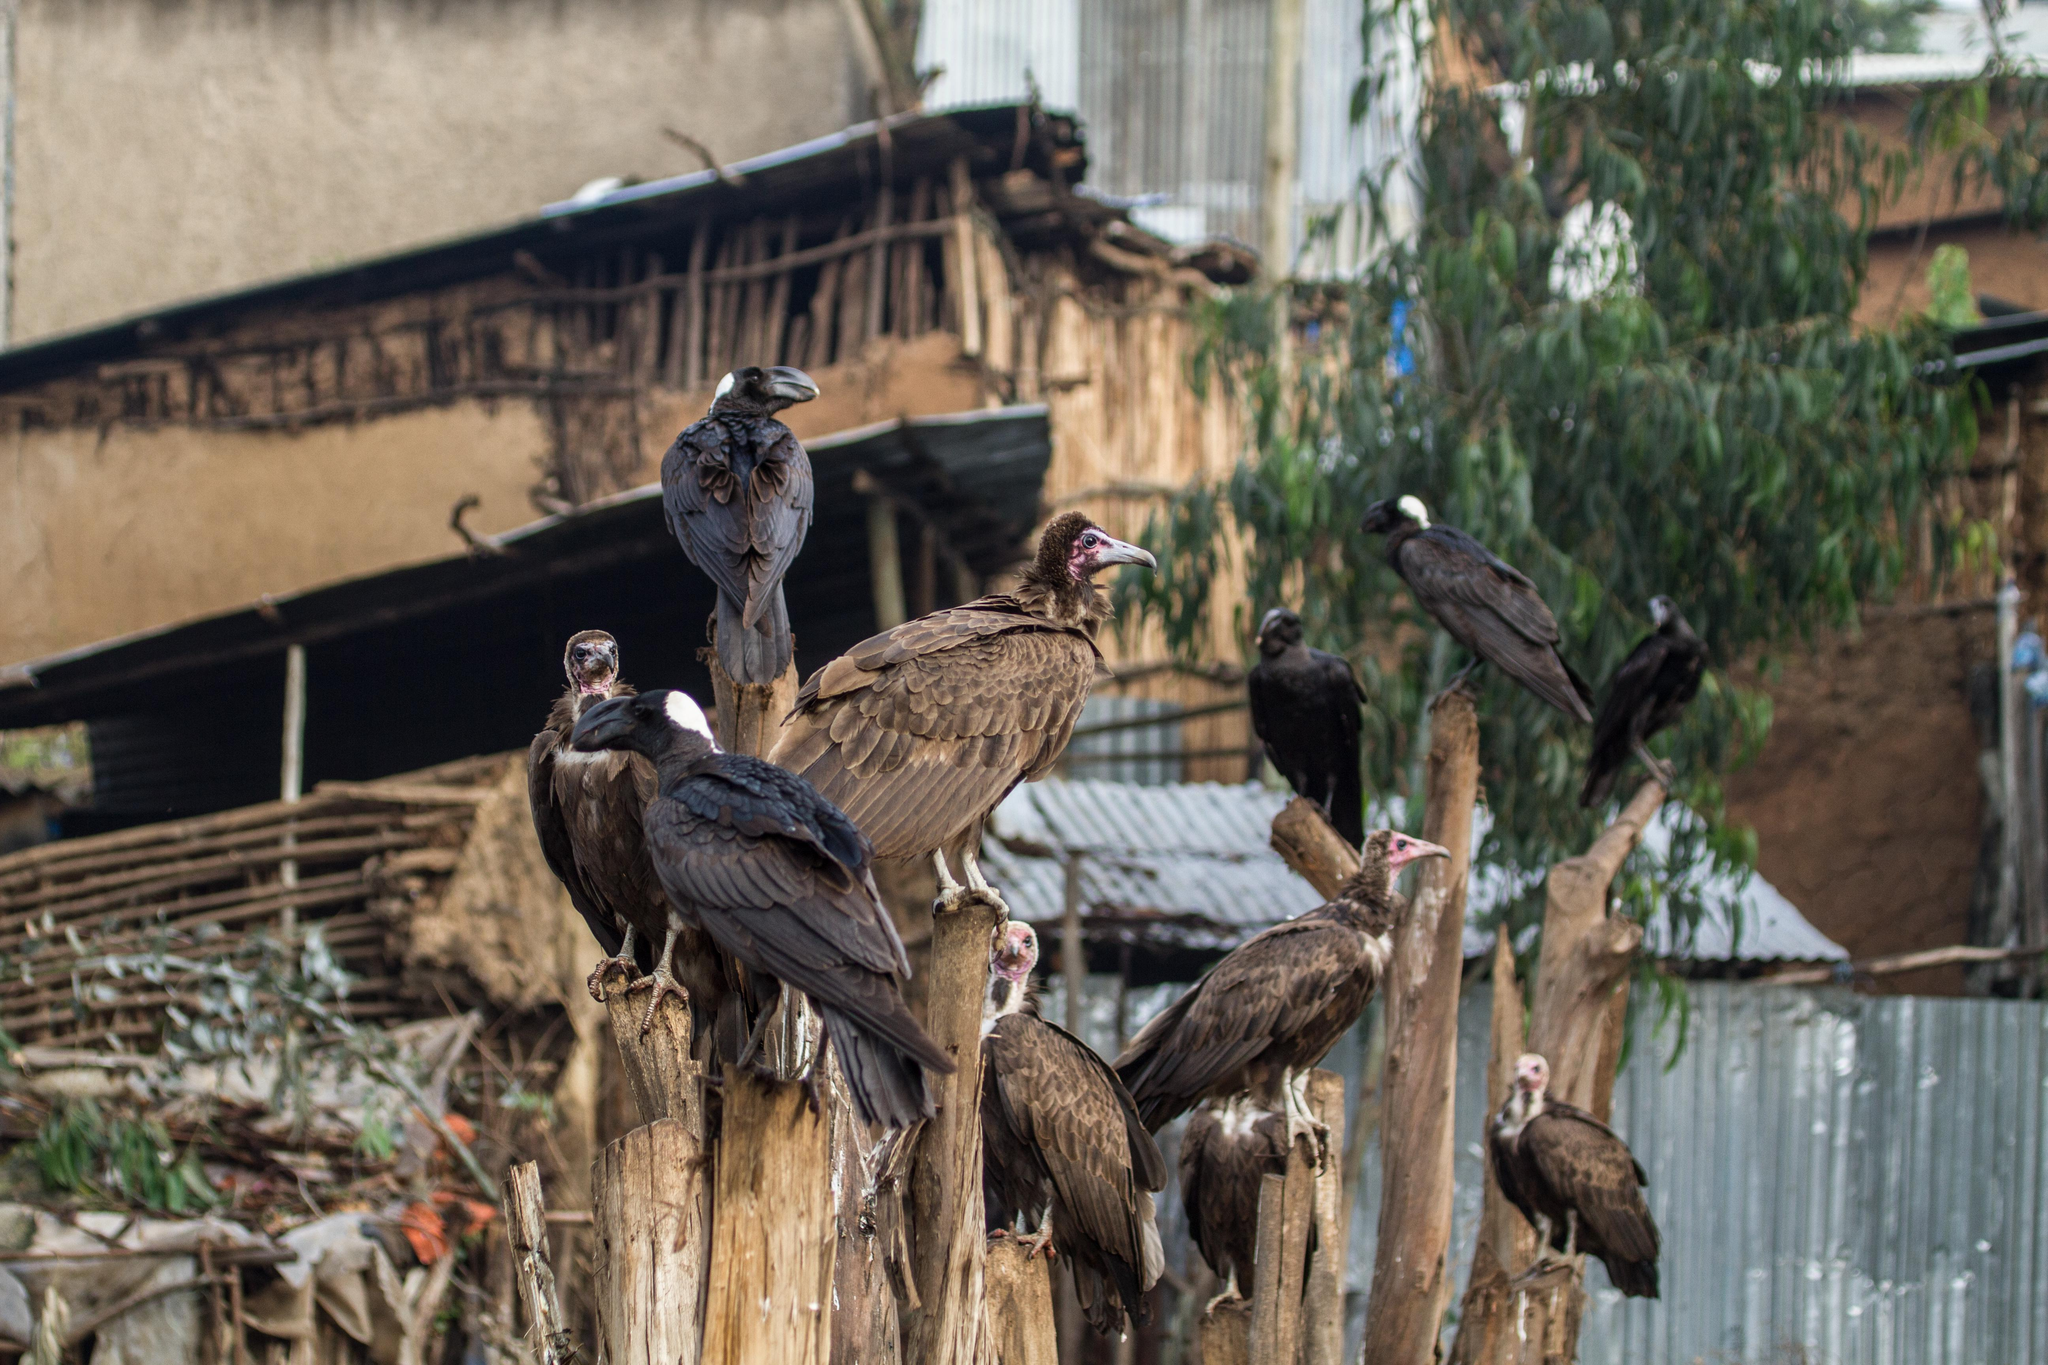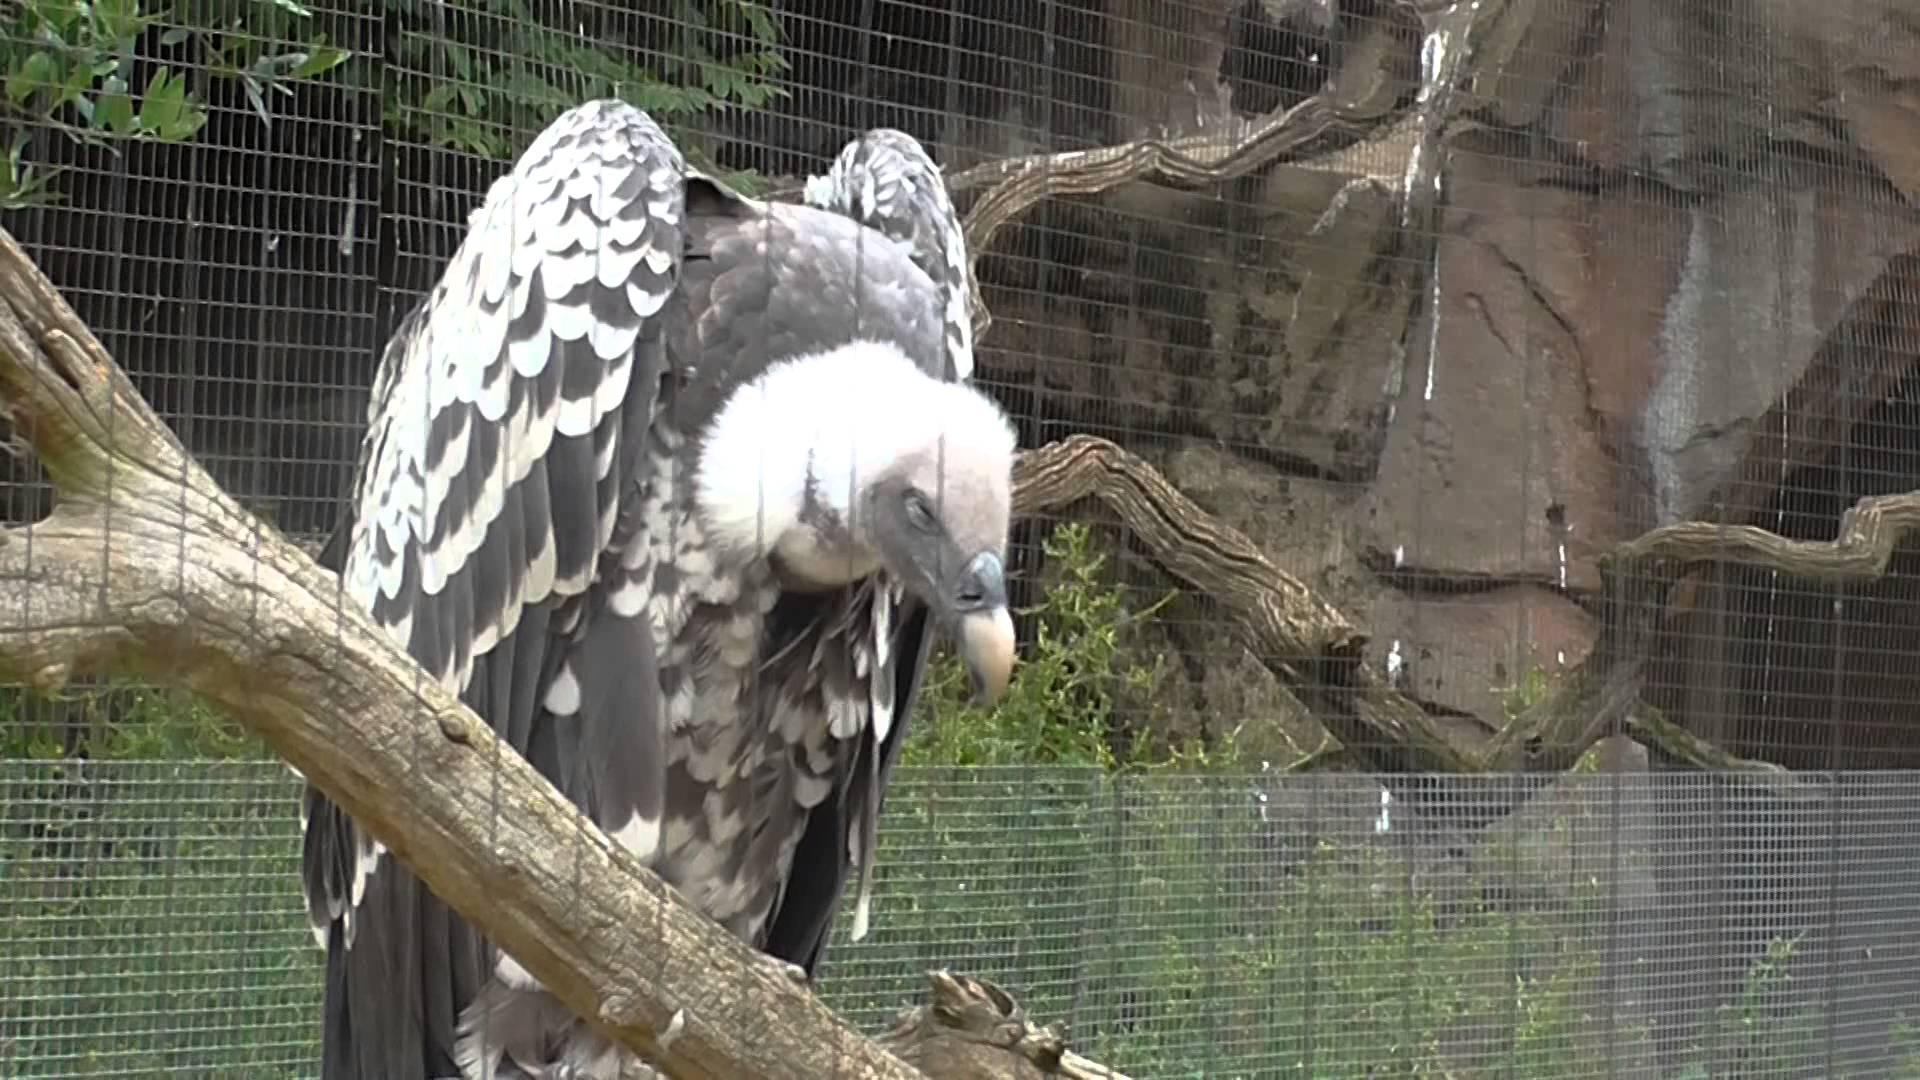The first image is the image on the left, the second image is the image on the right. Evaluate the accuracy of this statement regarding the images: "There are at most three ravens standing on a branch". Is it true? Answer yes or no. No. 